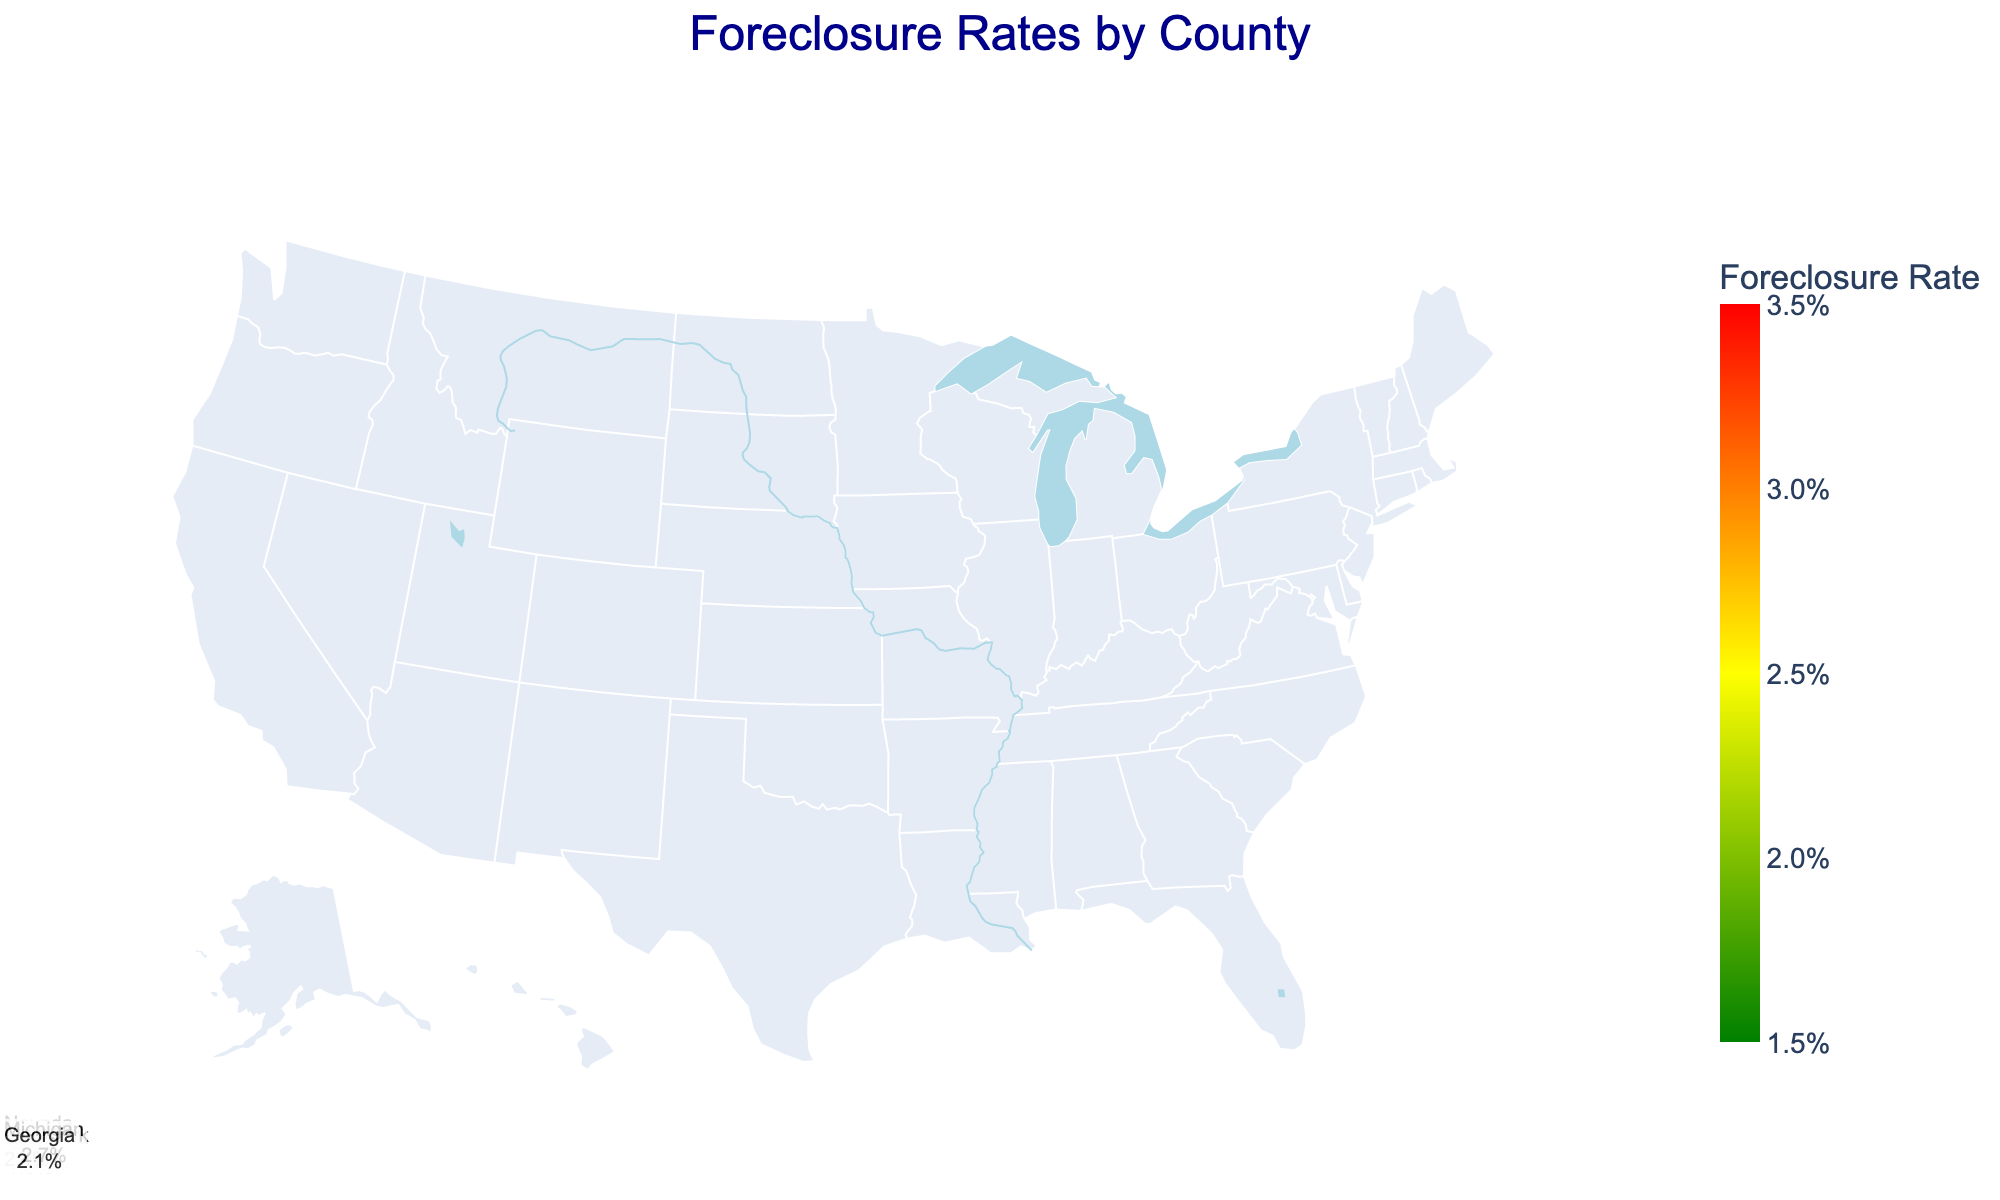What is the title of the chart? The title is usually placed at the top of the chart and is often larger or bold to make it stand out. In this chart, it is "Foreclosure Rates by County".
Answer: "Foreclosure Rates by County" What color represents lower foreclosure rates? In the color scale of the chart, lower foreclosure rates are indicated by greener shades.
Answer: Green Which county has the highest foreclosure rate? By examining the color intensities and using the hover tool, Clark County, Nevada shows the highest rate.
Answer: Clark County, Nevada How does the foreclosure rate in Los Angeles County compare to Miami-Dade County? Los Angeles County has a foreclosure rate of 0.021, while Miami-Dade County has a rate of 0.032. Therefore, Miami-Dade County's rate is higher.
Answer: Miami-Dade County has a higher rate What is the average foreclosure rate in Texas? Calculate the average of the rates for Harris and Dallas counties. (0.015 + 0.017) / 2 = 0.016
Answer: 0.016 Which state has the smallest range of foreclosure rates between its counties? To find the smallest range, calculate the difference between the highest and lowest rates in each state. For California: 0.021 - 0.018 = 0.003; For Florida: 0.032 - 0.025 = 0.007; Texas: 0.017 - 0.015 = 0.002; New York: 0.023 - 0.020 = 0.003; Illinois: 0.028 - 0.019 = 0.009; Arizona: 0.024 - 0.022 = 0.002; Nevada: 0.035 - 0.029 = 0.006; Ohio: 0.026 - 0.021 = 0.005; Michigan: 0.031 - 0.023 = 0.008; Georgia: 0.022 - 0.020 = 0.002. Texas, Arizona, and Georgia all tie with a range of 0.002.
Answer: Texas, Arizona, Georgia Which foreclosure rate is closer to 2%: Wayne County, Michigan or Franklin County, Ohio? Wayne County has a rate of 0.031, and Franklin County has a rate of 0.021. Since 2% is 0.020, Franklin County's rate of 0.021 is closer to 0.020.
Answer: Franklin County, Ohio What is the state with the highest average foreclosure rate? Calculate the average rates per state: California: (0.021+0.018)/2 = 0.0195; Florida: (0.032+0.025)/2 = 0.0285; Texas: (0.015+0.017)/2 = 0.016; New York: (0.023+0.020)/2 = 0.0215; Illinois: (0.028+0.019)/2 = 0.0235; Arizona: (0.024+0.022)/2 = 0.023; Nevada: (0.035+0.029)/2 = 0.032; Ohio: (0.026+0.021)/2 = 0.0235; Michigan: (0.031+0.023)/2 = 0.027; Georgia: (0.020+0.022)/2 = 0.021. Nevada has the highest average at 0.032.
Answer: Nevada Which counties in Illinois are shown and what are their foreclosure rates? The chart shows Cook County with a foreclosure rate of 0.028 and DuPage County with a rate of 0.019.
Answer: Cook (0.028), DuPage (0.019) What is the color scale legend title in the chart? The color scale legend title is located adjacent to the legend bar indicating it represents foreclosure rates. It is labeled "Foreclosure Rate".
Answer: "Foreclosure Rate" 